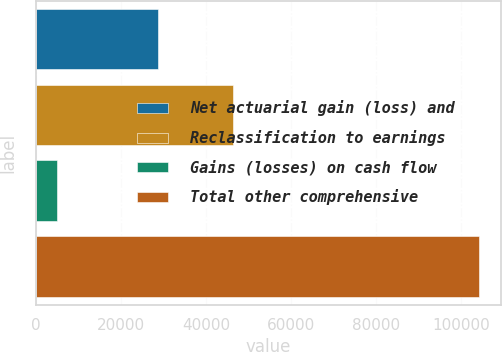Convert chart. <chart><loc_0><loc_0><loc_500><loc_500><bar_chart><fcel>Net actuarial gain (loss) and<fcel>Reclassification to earnings<fcel>Gains (losses) on cash flow<fcel>Total other comprehensive<nl><fcel>28718<fcel>46305<fcel>4931<fcel>104142<nl></chart> 